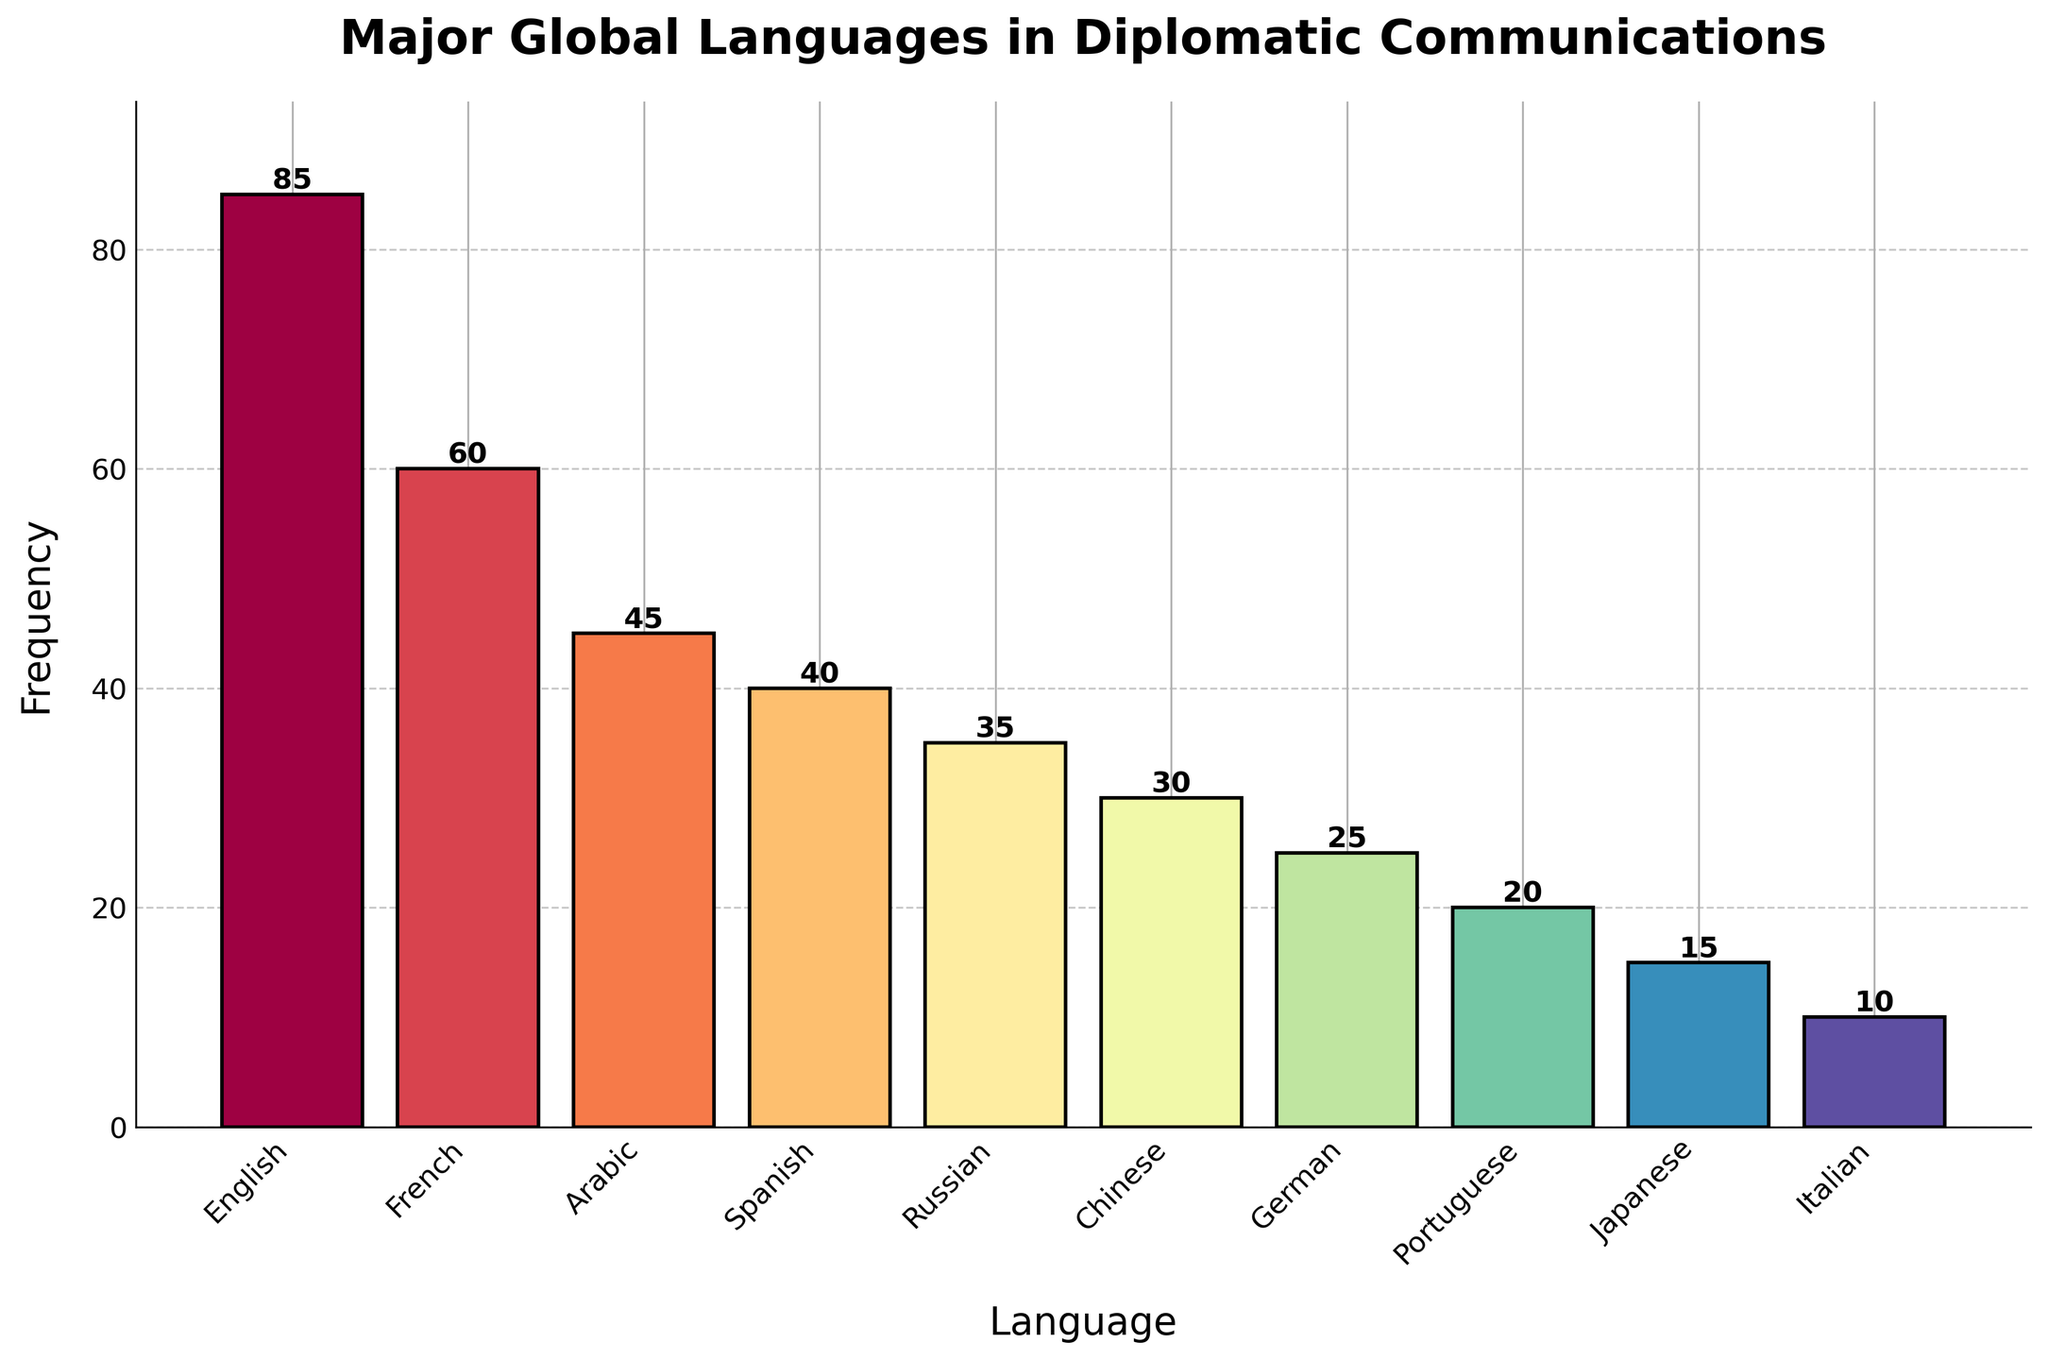Which language is the most frequently used in diplomatic communications? The bar representing English is the tallest bar in the chart, indicating it has the highest frequency. Therefore, English is the most frequently used language in diplomatic communications.
Answer: English Which language has a frequency exactly halfway between Arabic and German? Arabic has a frequency of 45 and German has 25. The halfway point is (45 + 25) / 2 = 35. The language with a frequency of 35 is Russian.
Answer: Russian Which languages are used more frequently than Portuguese but less frequently than French? By examining the heights of the bars, we find that Arabic and Spanish have frequencies more than Portuguese (20) and less than French (60).
Answer: Arabic and Spanish How many languages have a frequency of 30 or more but less than 50? We need to count the bars that fall within this range. Arabic (45), Spanish (40), and Russian (35) meet this criterion.
Answer: 3 What is the sum of the frequencies of the two least frequently used languages? The heights of the bars for Japanese and Italian (the two shortest bars) are 15 and 10, respectively. Their sum is 15 + 10.
Answer: 25 What is the total frequency of all European languages in the chart? European languages in the chart include English (85), French (60), Spanish (40), Russian (35), German (25), Portuguese (20), Italian (10). Their sum is 85 + 60 + 40 + 35 + 25 + 20 + 10.
Answer: 275 Which has a higher frequency, Chinese or German, and by how much? Comparing the heights of the bars, Chinese has a frequency of 30 and German has 25. The difference is 30 - 25.
Answer: Chinese by 5 What's the average frequency of the top three most used languages? The top three languages are English (85), French (60), and Arabic (45). Their sum is 85 + 60 + 45 = 190. The average is 190 / 3.
Answer: 63.33 How many languages have a frequency less than 30? The languages with frequencies less than 30 are German (25), Portuguese (20), Japanese (15), and Italian (10).
Answer: 4 Which language has double the frequency of Chinese? The height of the bar for Chinese is 30. Double this frequency is 2 * 30 = 60. The language with a frequency of 60 is French.
Answer: French 